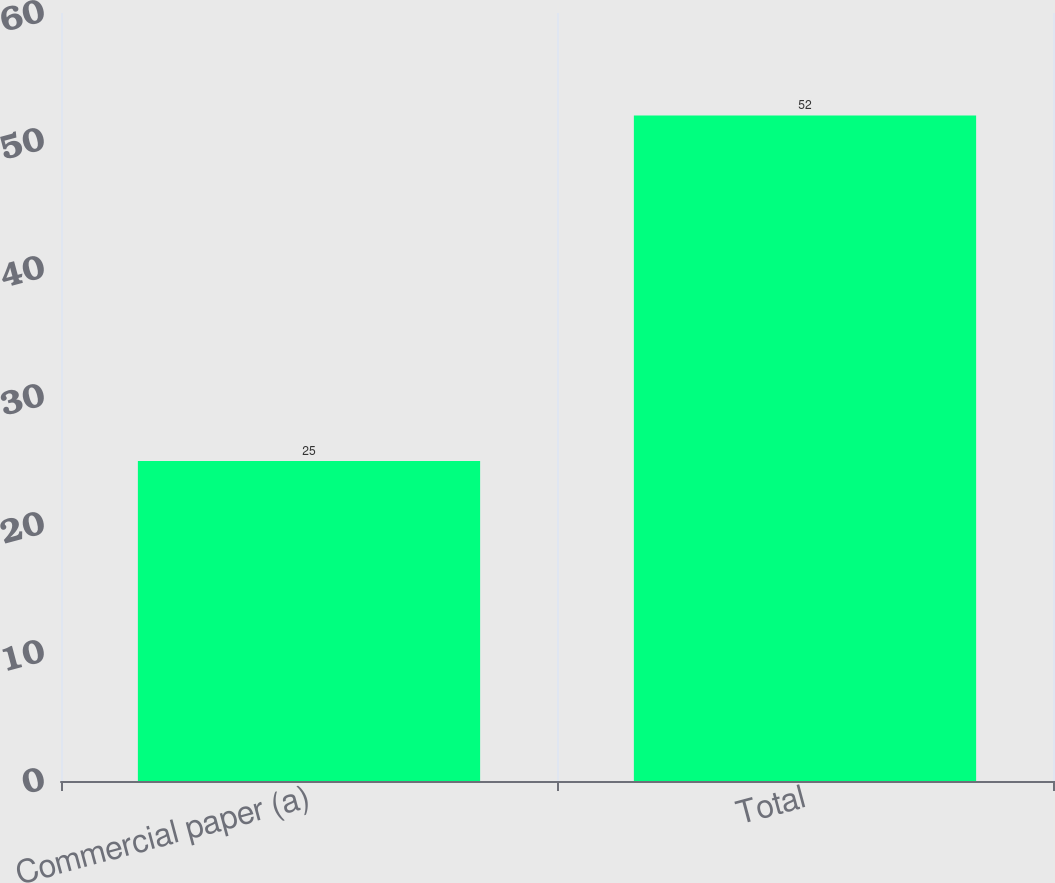Convert chart. <chart><loc_0><loc_0><loc_500><loc_500><bar_chart><fcel>Commercial paper (a)<fcel>Total<nl><fcel>25<fcel>52<nl></chart> 